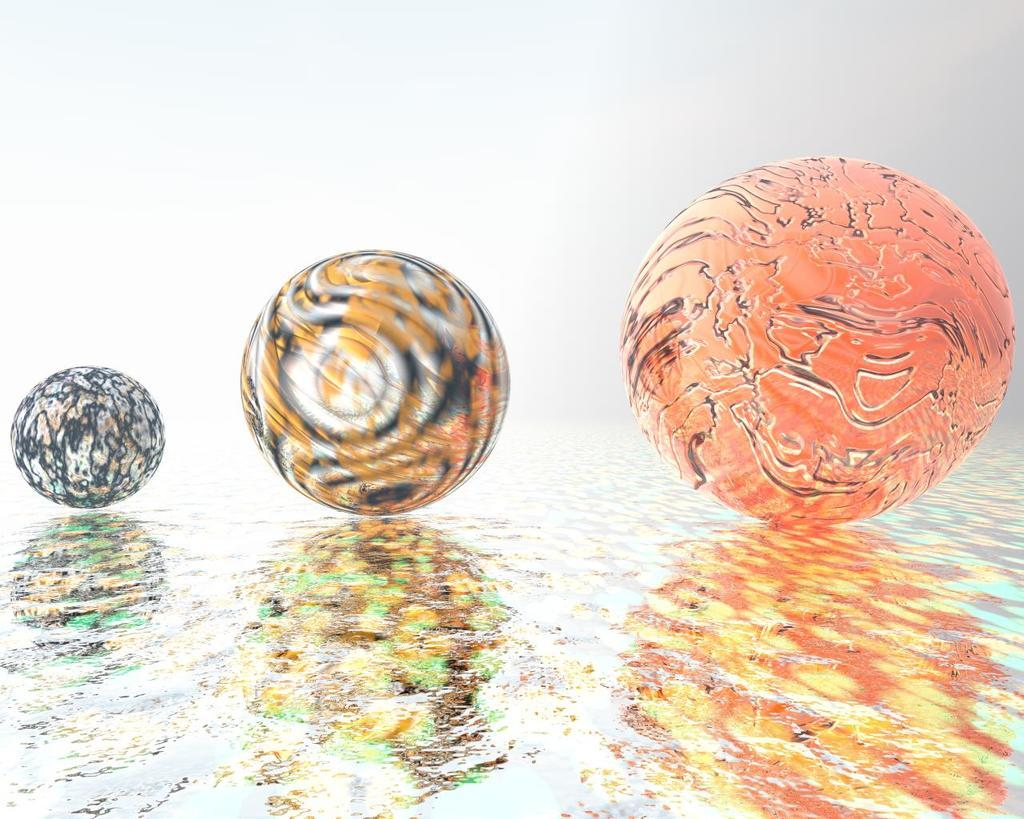What objects are present in the image? There are three spring balls in the image. Where are the spring balls located? The spring balls are on the floor. What type of meat is being served in the image? There is no meat present in the image; it features three spring balls on the floor. What nation is represented by the flag in the image? There is no flag present in the image, so it cannot be determined which nation is represented. 